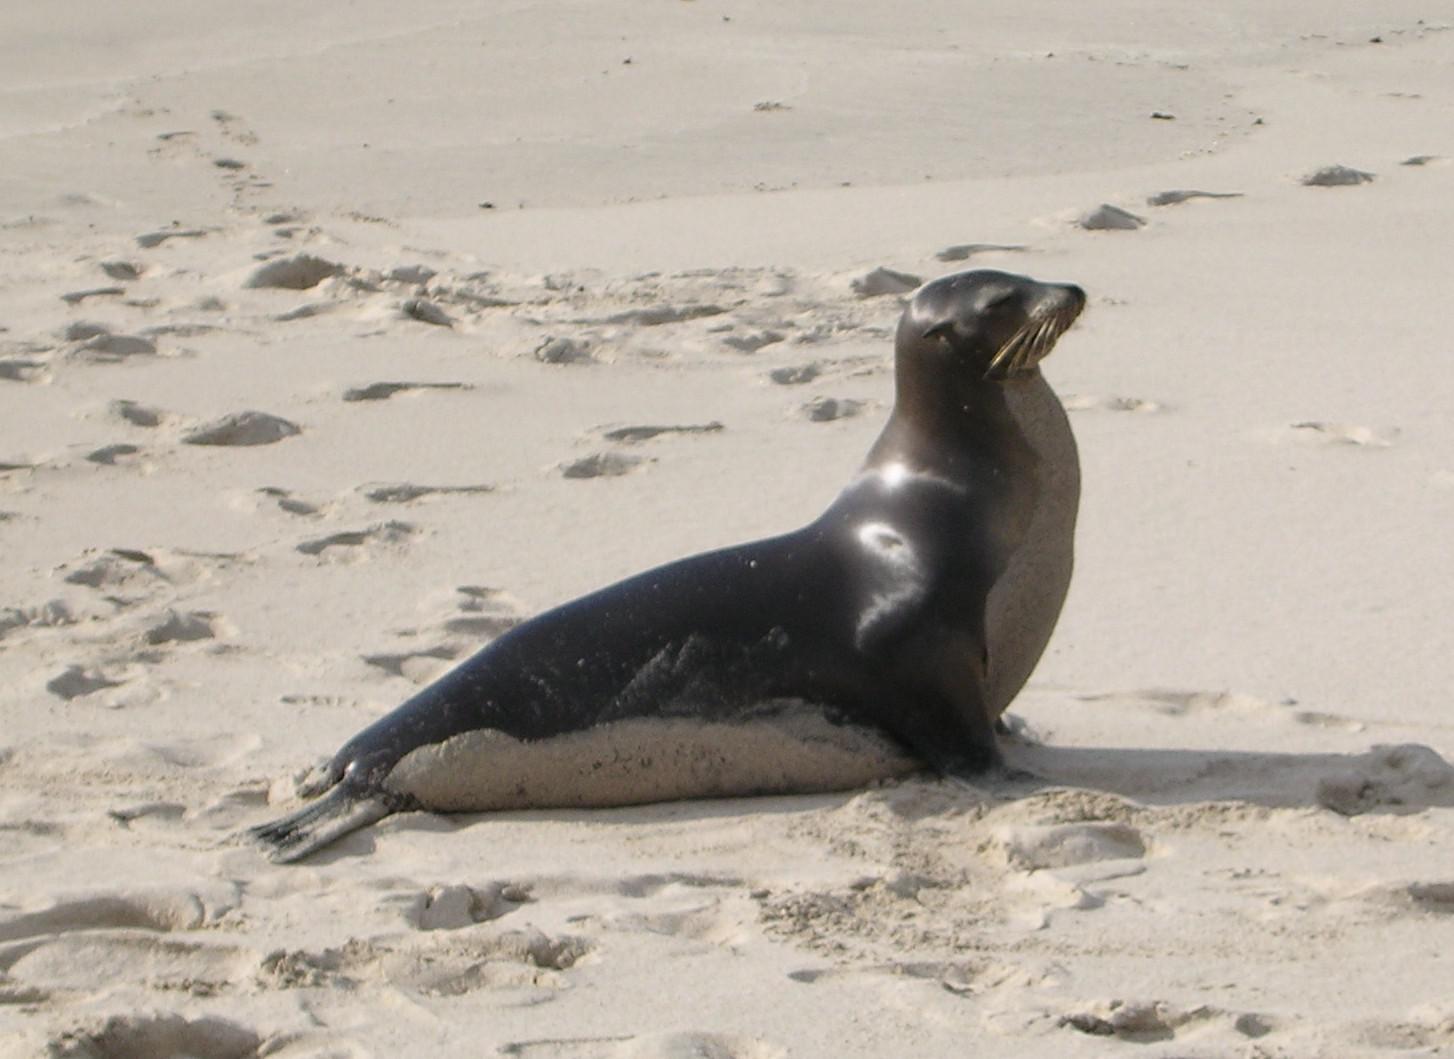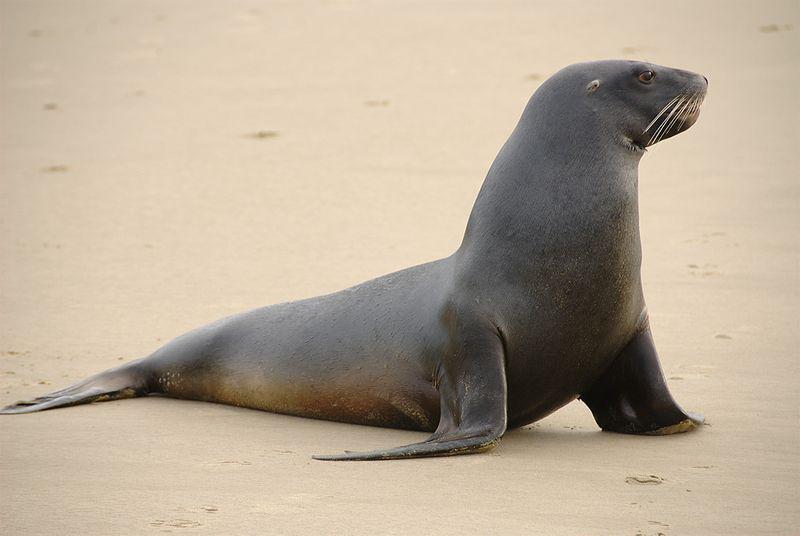The first image is the image on the left, the second image is the image on the right. Examine the images to the left and right. Is the description "there is a body of water on the right image" accurate? Answer yes or no. No. 